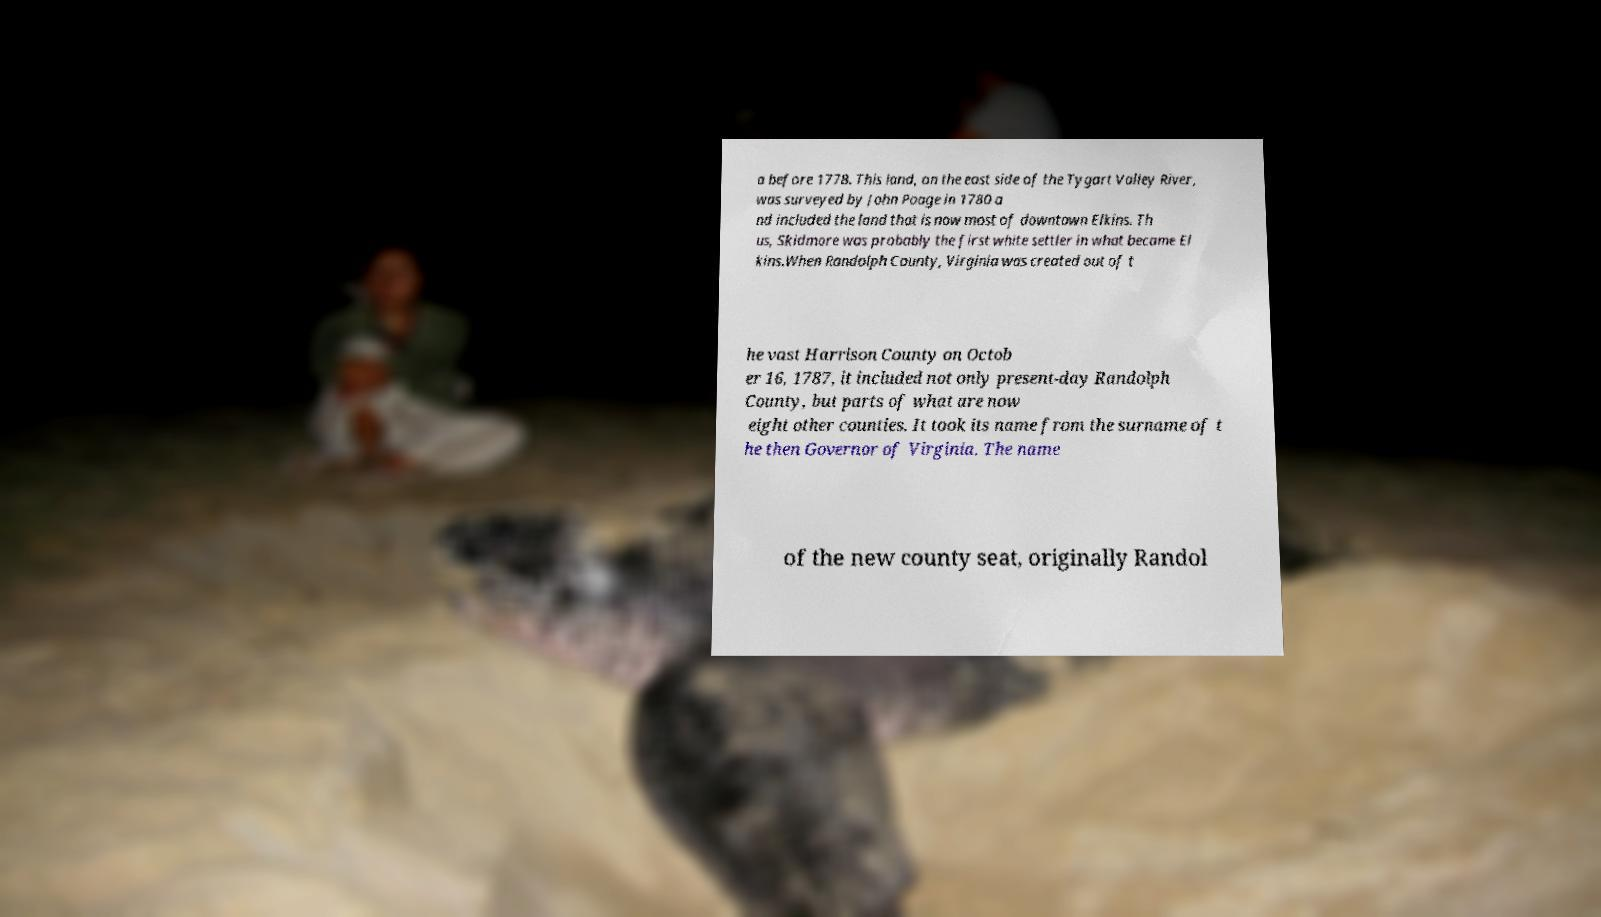There's text embedded in this image that I need extracted. Can you transcribe it verbatim? a before 1778. This land, on the east side of the Tygart Valley River, was surveyed by John Poage in 1780 a nd included the land that is now most of downtown Elkins. Th us, Skidmore was probably the first white settler in what became El kins.When Randolph County, Virginia was created out of t he vast Harrison County on Octob er 16, 1787, it included not only present-day Randolph County, but parts of what are now eight other counties. It took its name from the surname of t he then Governor of Virginia. The name of the new county seat, originally Randol 